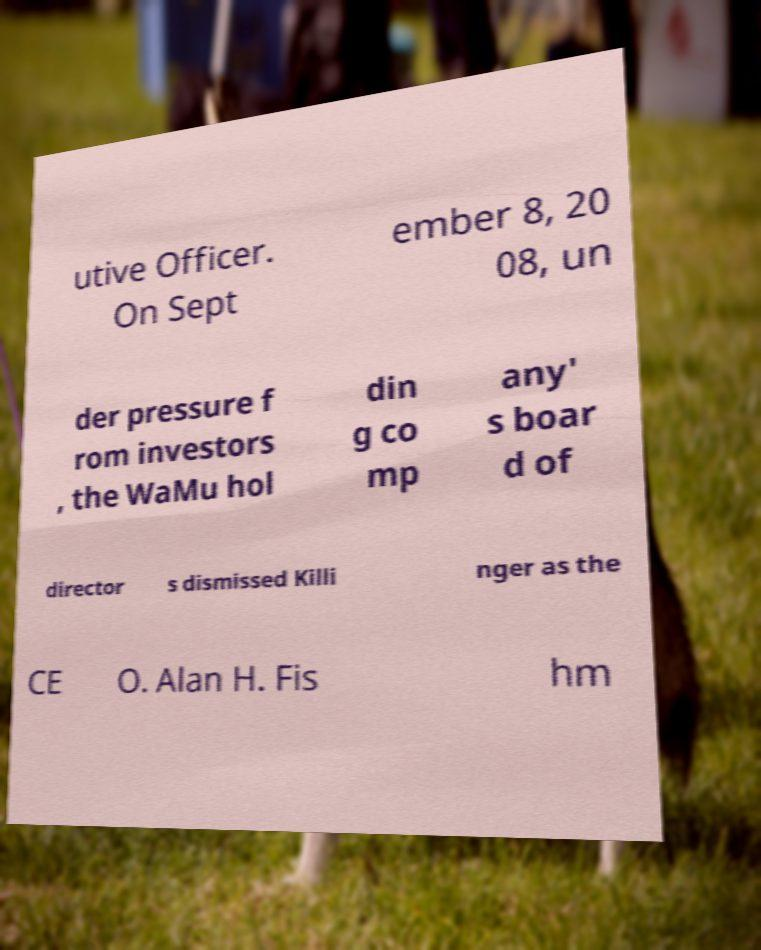Can you read and provide the text displayed in the image?This photo seems to have some interesting text. Can you extract and type it out for me? utive Officer. On Sept ember 8, 20 08, un der pressure f rom investors , the WaMu hol din g co mp any' s boar d of director s dismissed Killi nger as the CE O. Alan H. Fis hm 